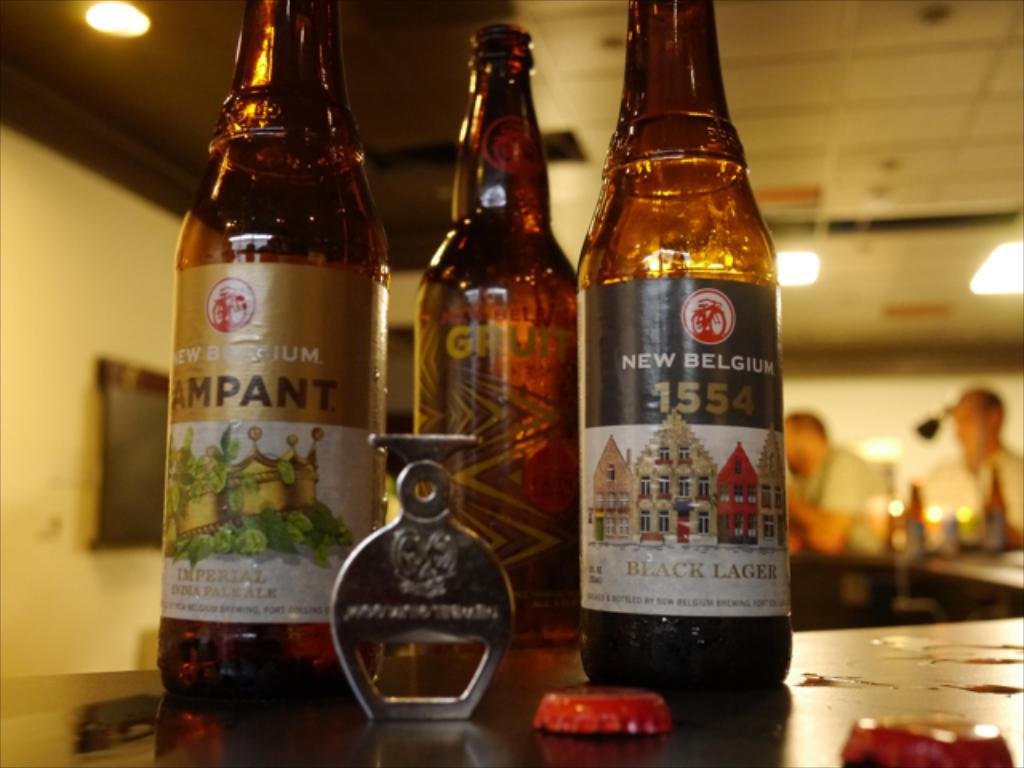Who made this beer?
Your answer should be very brief. New belgium. What year is on the bottle to the very right?
Your response must be concise. 1554. 